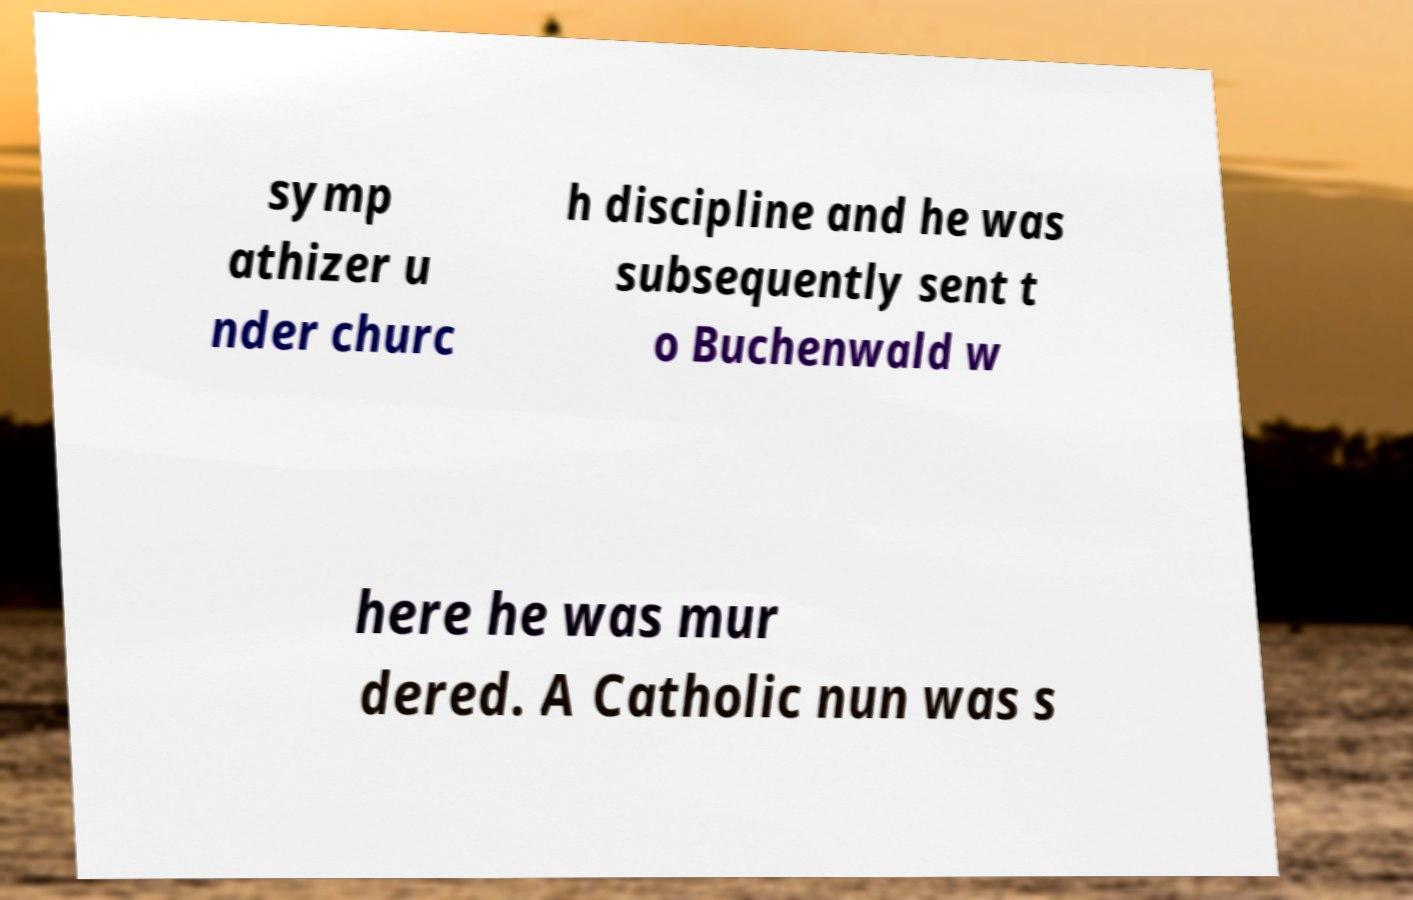Please read and relay the text visible in this image. What does it say? symp athizer u nder churc h discipline and he was subsequently sent t o Buchenwald w here he was mur dered. A Catholic nun was s 